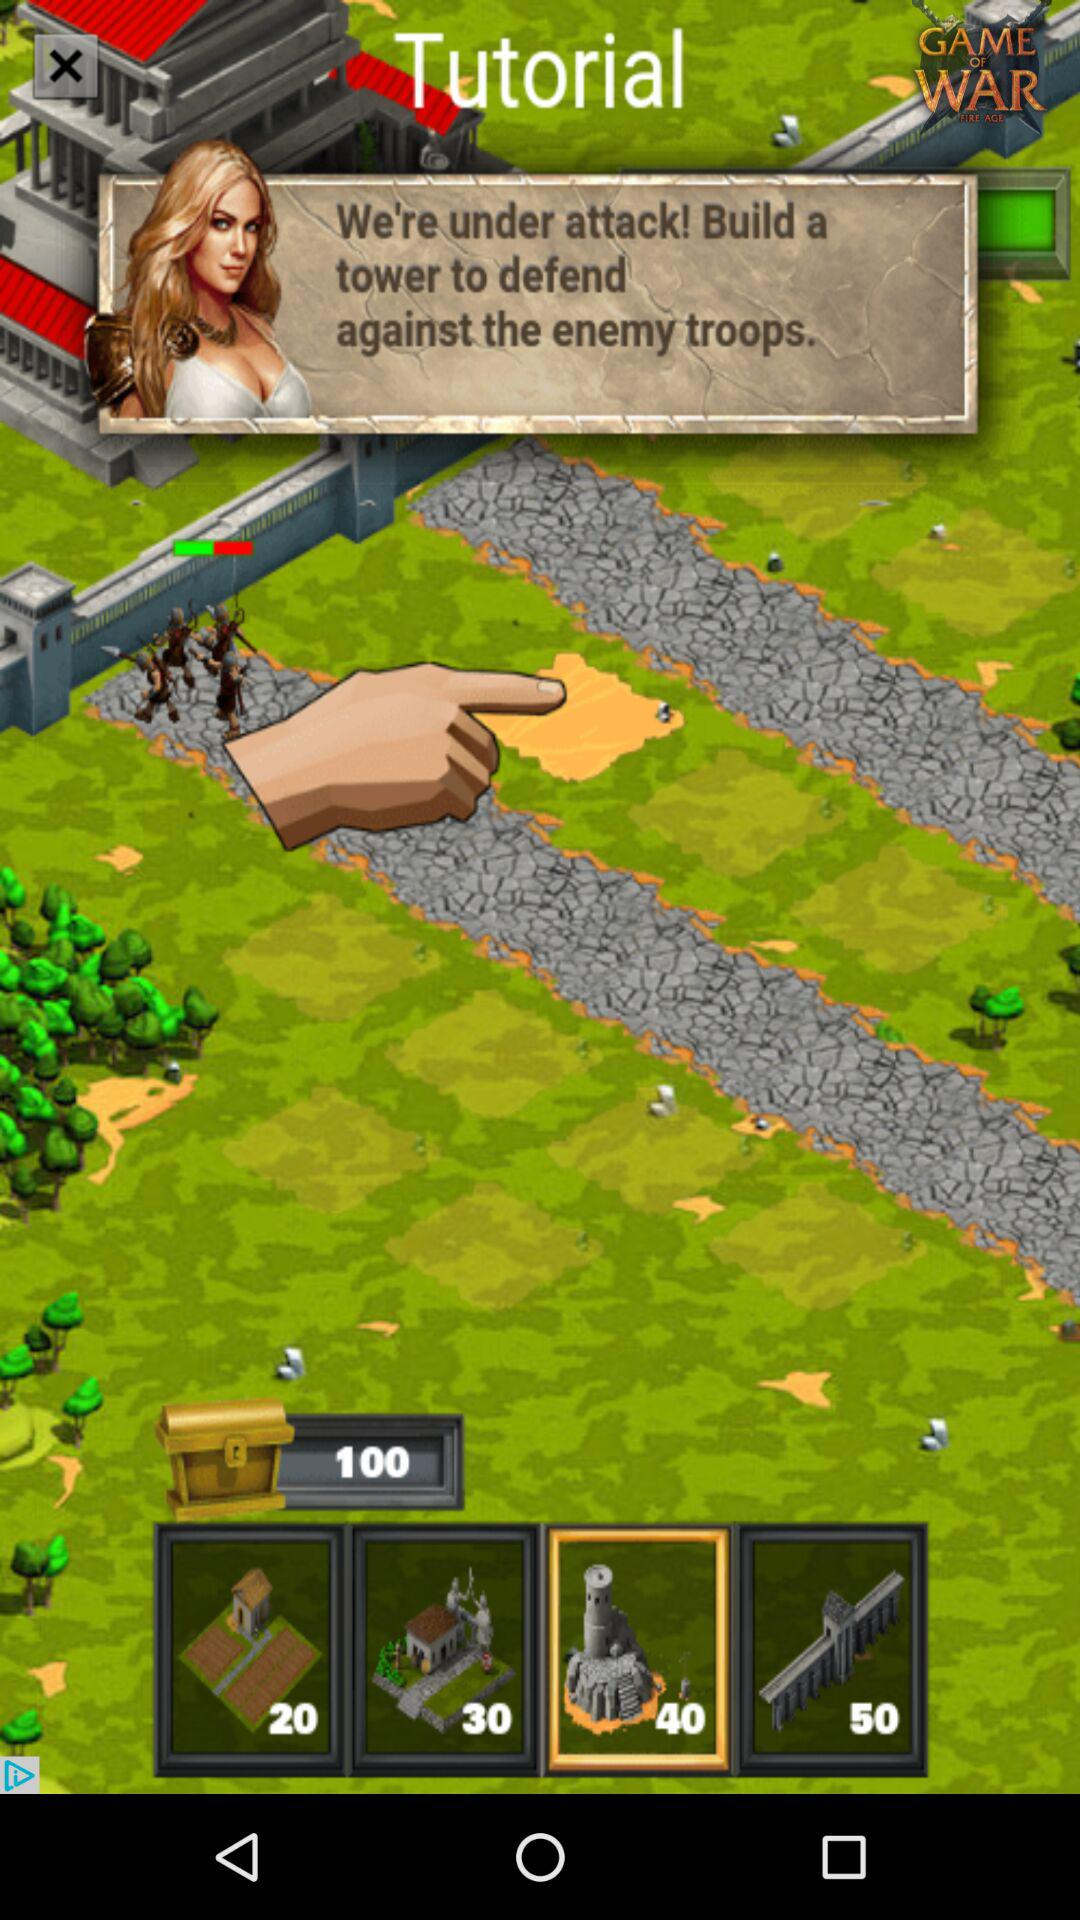How much more is the cost of the 50-gold tower than the 20-gold tower?
Answer the question using a single word or phrase. 30 